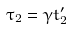Convert formula to latex. <formula><loc_0><loc_0><loc_500><loc_500>\tau _ { 2 } = \gamma t ^ { \prime } _ { 2 }</formula> 